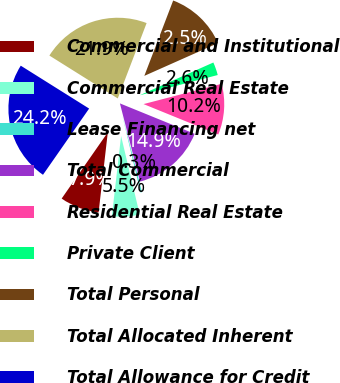<chart> <loc_0><loc_0><loc_500><loc_500><pie_chart><fcel>Commercial and Institutional<fcel>Commercial Real Estate<fcel>Lease Financing net<fcel>Total Commercial<fcel>Residential Real Estate<fcel>Private Client<fcel>Total Personal<fcel>Total Allocated Inherent<fcel>Total Allowance for Credit<nl><fcel>7.86%<fcel>5.53%<fcel>0.29%<fcel>14.85%<fcel>10.19%<fcel>2.62%<fcel>12.52%<fcel>21.9%<fcel>24.23%<nl></chart> 